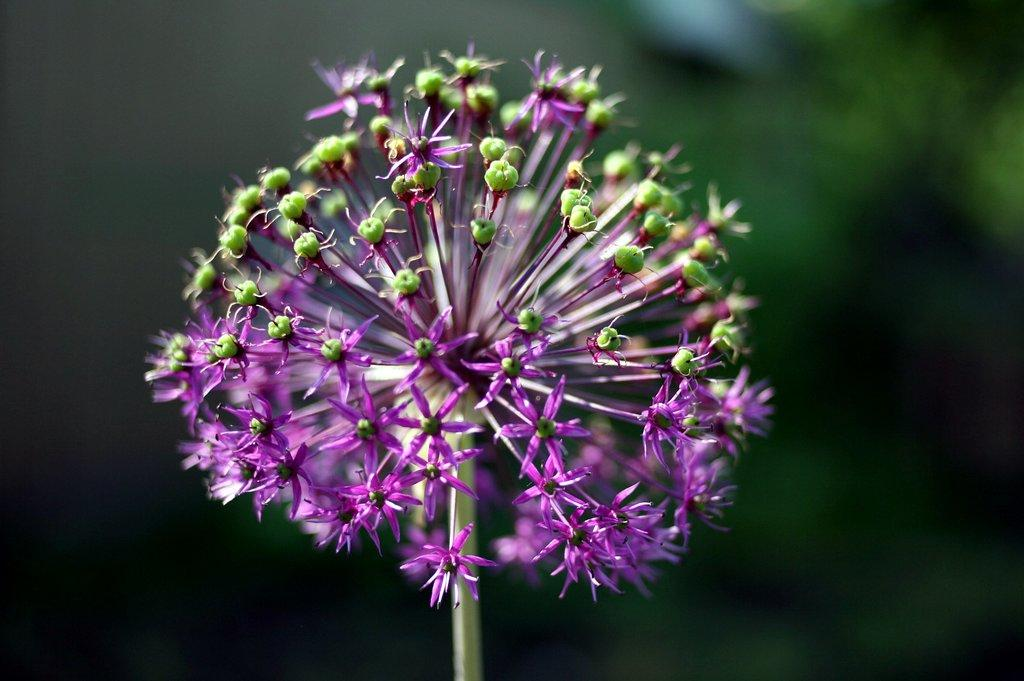Where was the image taken? The image was taken outdoors. What can be observed about the background of the image? The background of the image is blurred. What is the main subject of the image? There is a bunch of flowers on a plant in the middle of the image. What type of list can be seen in the image? There is no list present in the image; it features a bunch of flowers on a plant. What time of day is it in the image, as indicated by the watch? There is no watch present in the image, so it is not possible to determine the time of day. 